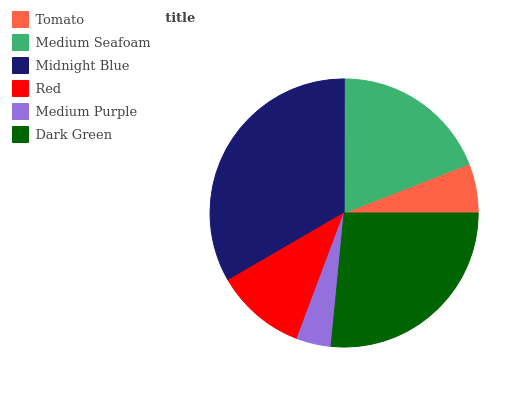Is Medium Purple the minimum?
Answer yes or no. Yes. Is Midnight Blue the maximum?
Answer yes or no. Yes. Is Medium Seafoam the minimum?
Answer yes or no. No. Is Medium Seafoam the maximum?
Answer yes or no. No. Is Medium Seafoam greater than Tomato?
Answer yes or no. Yes. Is Tomato less than Medium Seafoam?
Answer yes or no. Yes. Is Tomato greater than Medium Seafoam?
Answer yes or no. No. Is Medium Seafoam less than Tomato?
Answer yes or no. No. Is Medium Seafoam the high median?
Answer yes or no. Yes. Is Red the low median?
Answer yes or no. Yes. Is Medium Purple the high median?
Answer yes or no. No. Is Dark Green the low median?
Answer yes or no. No. 